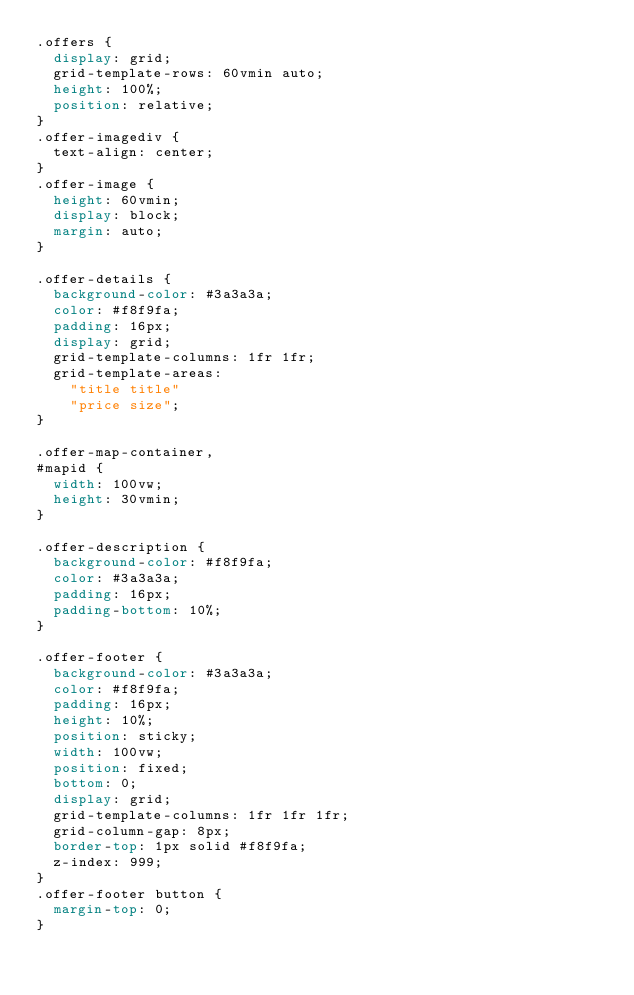<code> <loc_0><loc_0><loc_500><loc_500><_CSS_>.offers {
  display: grid;
  grid-template-rows: 60vmin auto;
  height: 100%;
  position: relative;
}
.offer-imagediv {
  text-align: center;
}
.offer-image {
  height: 60vmin;
  display: block;
  margin: auto;
}

.offer-details {
  background-color: #3a3a3a;
  color: #f8f9fa;
  padding: 16px;
  display: grid;
  grid-template-columns: 1fr 1fr;
  grid-template-areas:
    "title title"
    "price size";
}

.offer-map-container,
#mapid {
  width: 100vw;
  height: 30vmin;
}

.offer-description {
  background-color: #f8f9fa;
  color: #3a3a3a;
  padding: 16px;
  padding-bottom: 10%;
}

.offer-footer {
  background-color: #3a3a3a;
  color: #f8f9fa;
  padding: 16px;
  height: 10%;
  position: sticky;
  width: 100vw;
  position: fixed;
  bottom: 0;
  display: grid;
  grid-template-columns: 1fr 1fr 1fr;
  grid-column-gap: 8px;
  border-top: 1px solid #f8f9fa;
  z-index: 999;
}
.offer-footer button {
  margin-top: 0;
}
</code> 